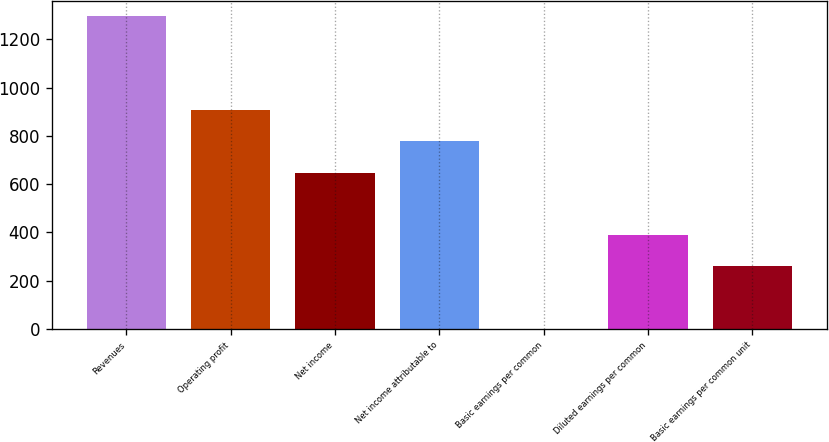Convert chart to OTSL. <chart><loc_0><loc_0><loc_500><loc_500><bar_chart><fcel>Revenues<fcel>Operating profit<fcel>Net income<fcel>Net income attributable to<fcel>Basic earnings per common<fcel>Diluted earnings per common<fcel>Basic earnings per common unit<nl><fcel>1295<fcel>906.57<fcel>647.59<fcel>777.08<fcel>0.14<fcel>388.61<fcel>259.12<nl></chart> 